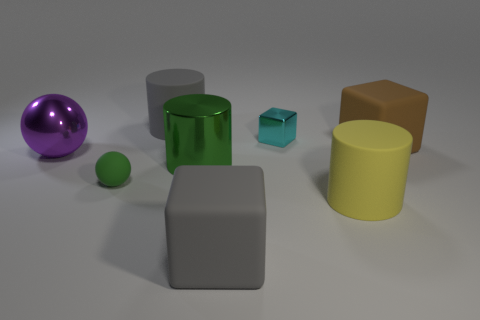Subtract all rubber cylinders. How many cylinders are left? 1 Subtract all green cylinders. How many cylinders are left? 2 Add 2 big yellow rubber objects. How many objects exist? 10 Subtract all cubes. How many objects are left? 5 Subtract 1 cylinders. How many cylinders are left? 2 Subtract all yellow blocks. Subtract all green cylinders. How many blocks are left? 3 Subtract all cyan cylinders. How many cyan cubes are left? 1 Subtract all small blocks. Subtract all green spheres. How many objects are left? 6 Add 8 brown things. How many brown things are left? 9 Add 4 large purple shiny things. How many large purple shiny things exist? 5 